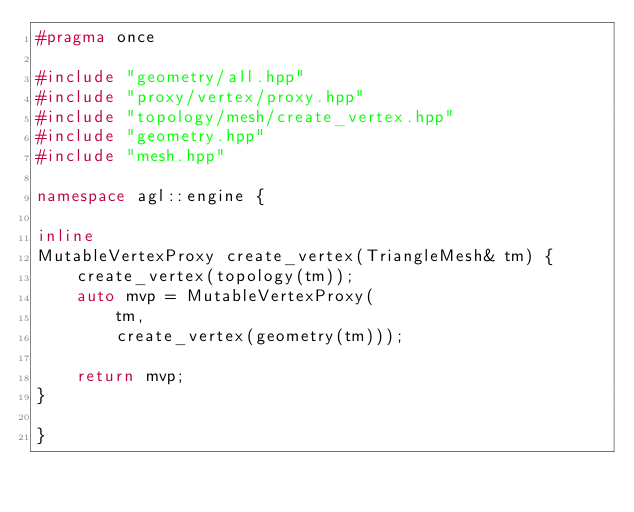Convert code to text. <code><loc_0><loc_0><loc_500><loc_500><_C++_>#pragma once

#include "geometry/all.hpp"
#include "proxy/vertex/proxy.hpp"
#include "topology/mesh/create_vertex.hpp"
#include "geometry.hpp"
#include "mesh.hpp"

namespace agl::engine {

inline
MutableVertexProxy create_vertex(TriangleMesh& tm) {
    create_vertex(topology(tm));
    auto mvp = MutableVertexProxy(
        tm,
        create_vertex(geometry(tm)));

    return mvp;
}

}
</code> 